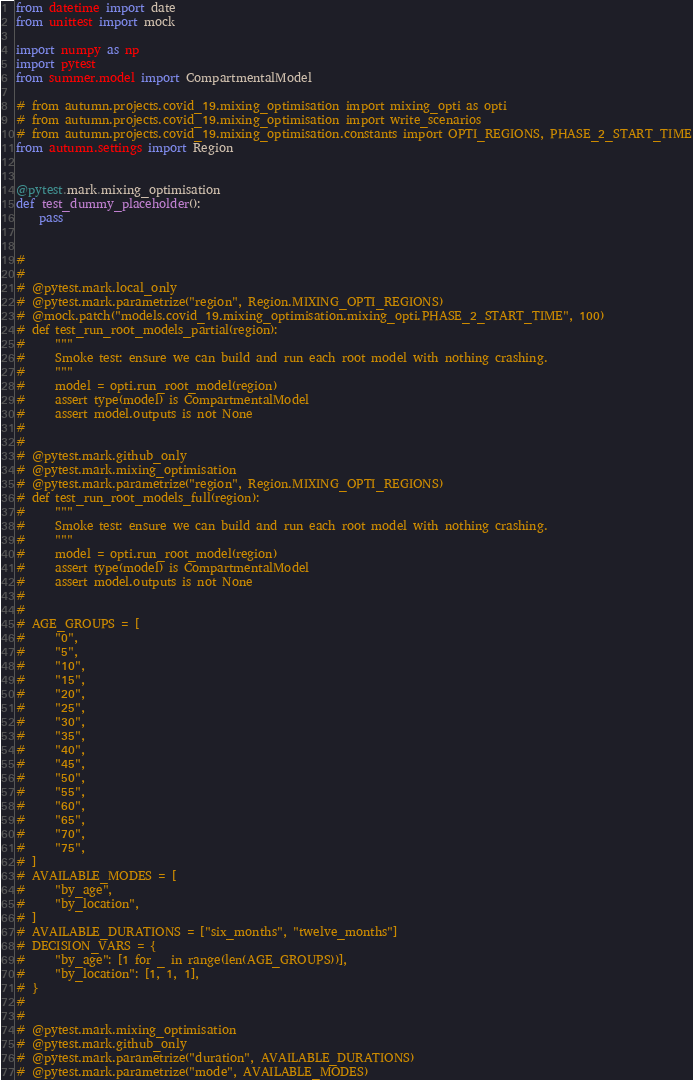<code> <loc_0><loc_0><loc_500><loc_500><_Python_>from datetime import date
from unittest import mock

import numpy as np
import pytest
from summer.model import CompartmentalModel

# from autumn.projects.covid_19.mixing_optimisation import mixing_opti as opti
# from autumn.projects.covid_19.mixing_optimisation import write_scenarios
# from autumn.projects.covid_19.mixing_optimisation.constants import OPTI_REGIONS, PHASE_2_START_TIME
from autumn.settings import Region


@pytest.mark.mixing_optimisation
def test_dummy_placeholder():
    pass


#
#
# @pytest.mark.local_only
# @pytest.mark.parametrize("region", Region.MIXING_OPTI_REGIONS)
# @mock.patch("models.covid_19.mixing_optimisation.mixing_opti.PHASE_2_START_TIME", 100)
# def test_run_root_models_partial(region):
#     """
#     Smoke test: ensure we can build and run each root model with nothing crashing.
#     """
#     model = opti.run_root_model(region)
#     assert type(model) is CompartmentalModel
#     assert model.outputs is not None
#
#
# @pytest.mark.github_only
# @pytest.mark.mixing_optimisation
# @pytest.mark.parametrize("region", Region.MIXING_OPTI_REGIONS)
# def test_run_root_models_full(region):
#     """
#     Smoke test: ensure we can build and run each root model with nothing crashing.
#     """
#     model = opti.run_root_model(region)
#     assert type(model) is CompartmentalModel
#     assert model.outputs is not None
#
#
# AGE_GROUPS = [
#     "0",
#     "5",
#     "10",
#     "15",
#     "20",
#     "25",
#     "30",
#     "35",
#     "40",
#     "45",
#     "50",
#     "55",
#     "60",
#     "65",
#     "70",
#     "75",
# ]
# AVAILABLE_MODES = [
#     "by_age",
#     "by_location",
# ]
# AVAILABLE_DURATIONS = ["six_months", "twelve_months"]
# DECISION_VARS = {
#     "by_age": [1 for _ in range(len(AGE_GROUPS))],
#     "by_location": [1, 1, 1],
# }
#
#
# @pytest.mark.mixing_optimisation
# @pytest.mark.github_only
# @pytest.mark.parametrize("duration", AVAILABLE_DURATIONS)
# @pytest.mark.parametrize("mode", AVAILABLE_MODES)</code> 